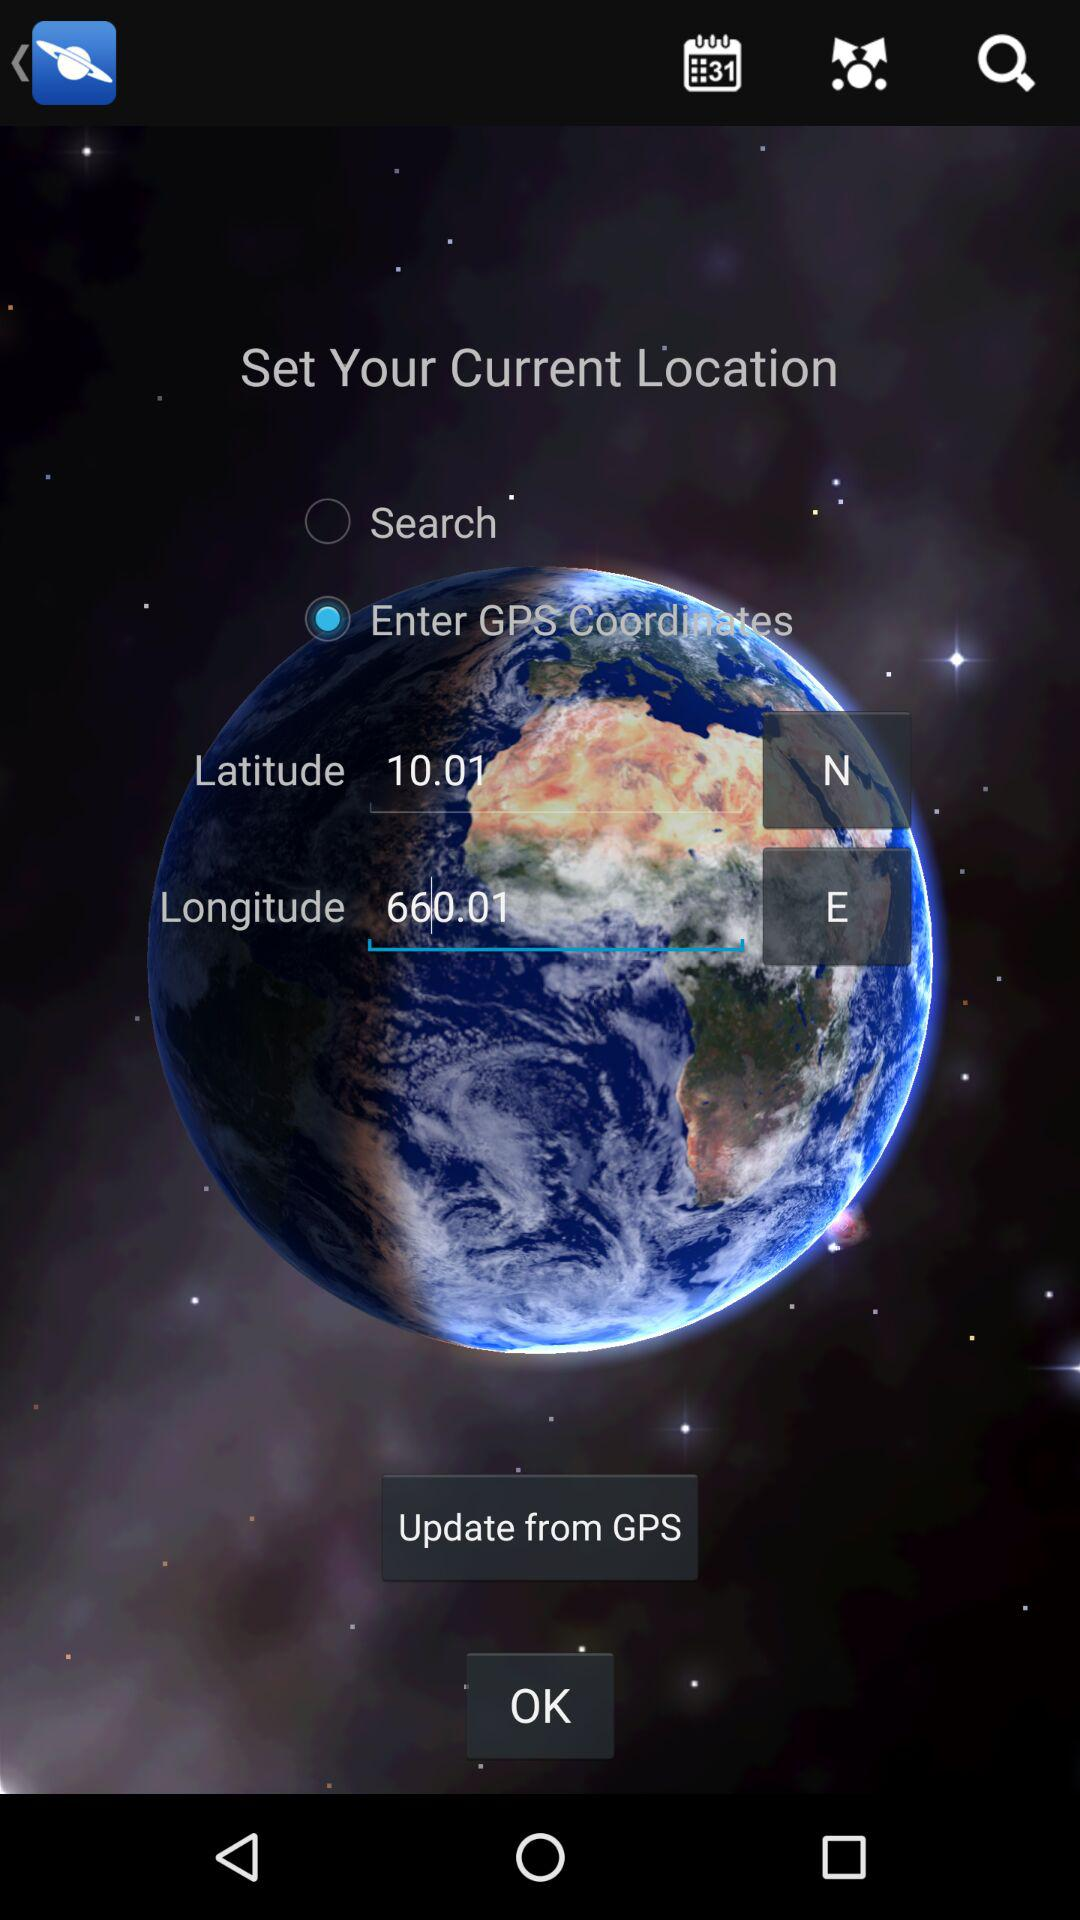Which option is selected for "Set Your Current Location"? The selected option is "Enter GPS Coordinates". 